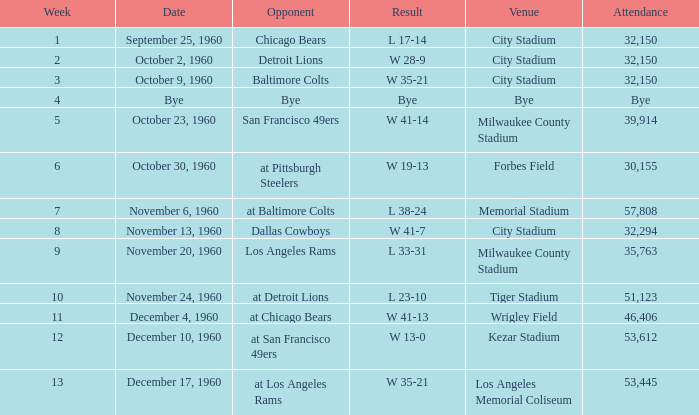What amount of persons visited the tiger stadium? L 23-10. 